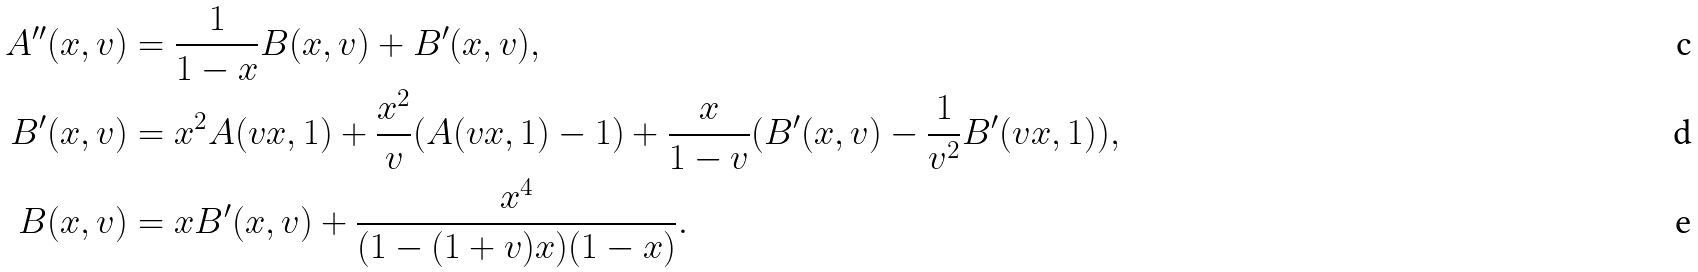<formula> <loc_0><loc_0><loc_500><loc_500>A ^ { \prime \prime } ( x , v ) & = \frac { 1 } { 1 - x } B ( x , v ) + B ^ { \prime } ( x , v ) , \\ B ^ { \prime } ( x , v ) & = x ^ { 2 } A ( v x , 1 ) + \frac { x ^ { 2 } } { v } ( A ( v x , 1 ) - 1 ) + \frac { x } { 1 - v } ( B ^ { \prime } ( x , v ) - \frac { 1 } { v ^ { 2 } } B ^ { \prime } ( v x , 1 ) ) , \\ B ( x , v ) & = x B ^ { \prime } ( x , v ) + \frac { x ^ { 4 } } { ( 1 - ( 1 + v ) x ) ( 1 - x ) } .</formula> 